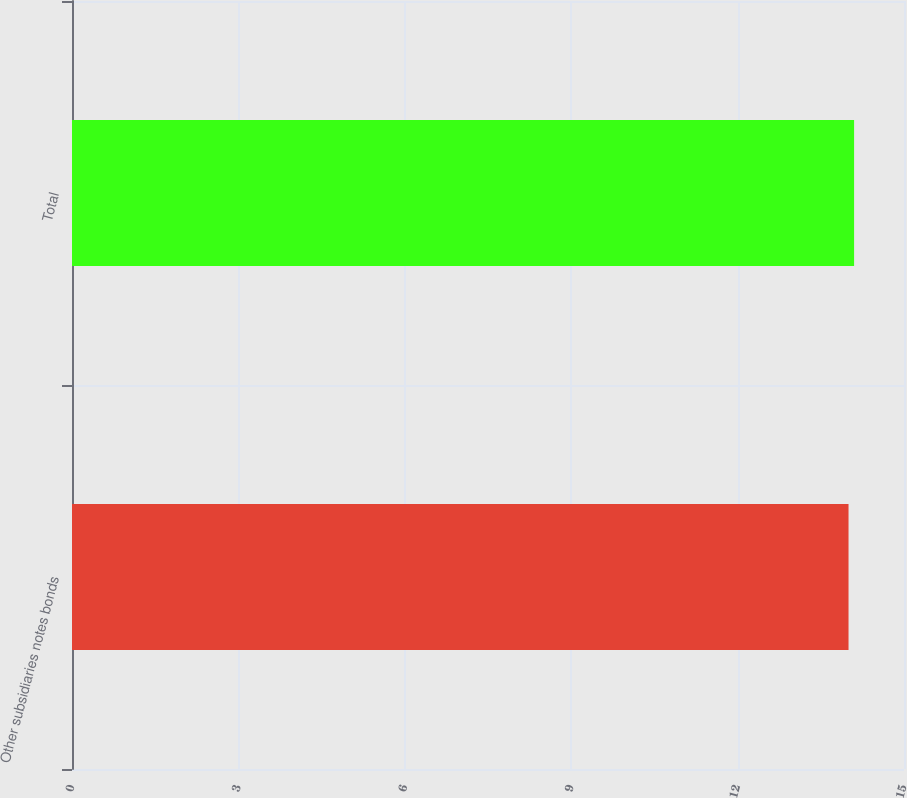Convert chart. <chart><loc_0><loc_0><loc_500><loc_500><bar_chart><fcel>Other subsidiaries notes bonds<fcel>Total<nl><fcel>14<fcel>14.1<nl></chart> 